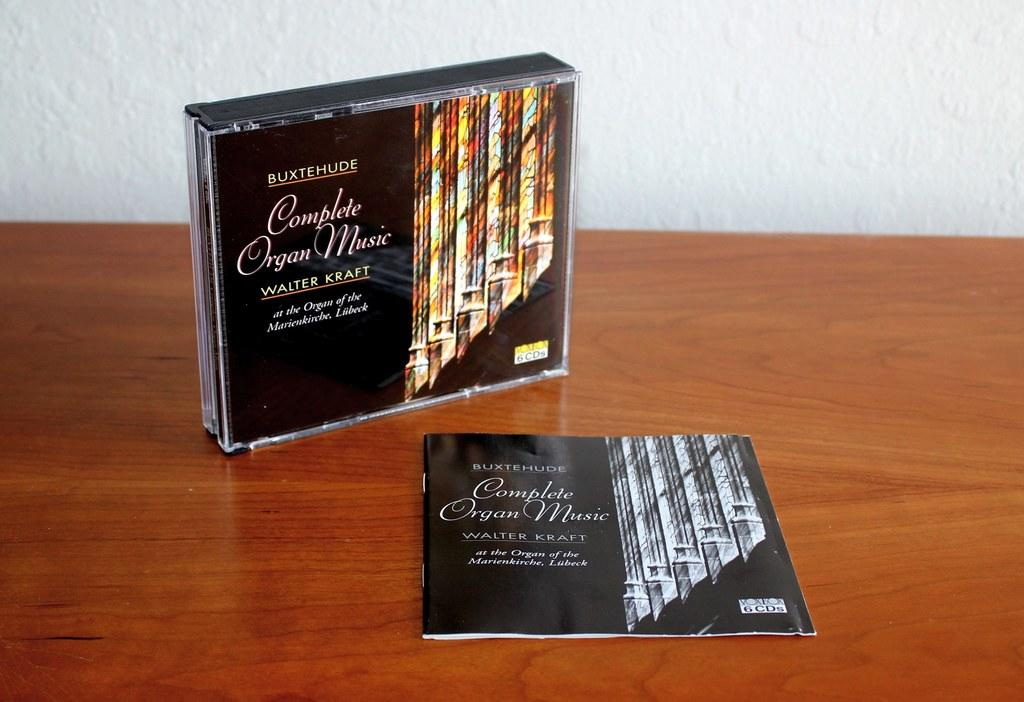<image>
Create a compact narrative representing the image presented. A CD case for Complete Organ Music sits on a wooden table 